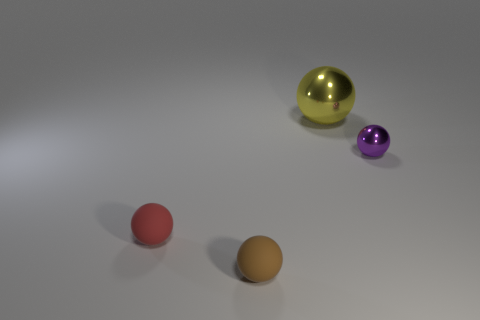Add 2 brown things. How many objects exist? 6 Add 1 tiny gray shiny things. How many tiny gray shiny things exist? 1 Subtract 0 green cylinders. How many objects are left? 4 Subtract all brown rubber balls. Subtract all matte balls. How many objects are left? 1 Add 3 tiny metal things. How many tiny metal things are left? 4 